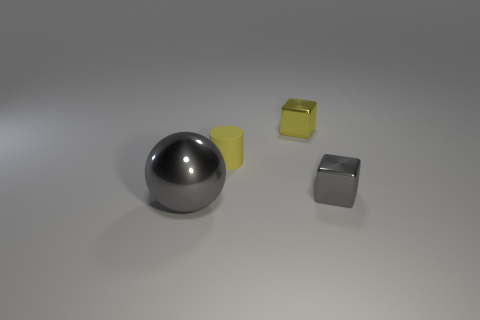Are there any small gray cubes made of the same material as the large ball?
Make the answer very short. Yes. The thing that is to the right of the thing that is behind the small rubber object is what color?
Offer a terse response. Gray. Does the yellow metallic thing have the same size as the gray shiny cube?
Your response must be concise. Yes. What number of balls are either tiny yellow matte objects or large metal objects?
Make the answer very short. 1. There is a tiny block that is to the right of the yellow metal object; what number of tiny things are behind it?
Ensure brevity in your answer.  2. Is the shape of the small gray shiny thing the same as the small yellow shiny object?
Your response must be concise. Yes. What is the size of the yellow metal object that is the same shape as the small gray metal thing?
Offer a very short reply. Small. There is a gray shiny thing in front of the gray shiny object right of the large gray thing; what shape is it?
Your response must be concise. Sphere. How big is the rubber cylinder?
Give a very brief answer. Small. What shape is the small rubber thing?
Provide a short and direct response. Cylinder. 